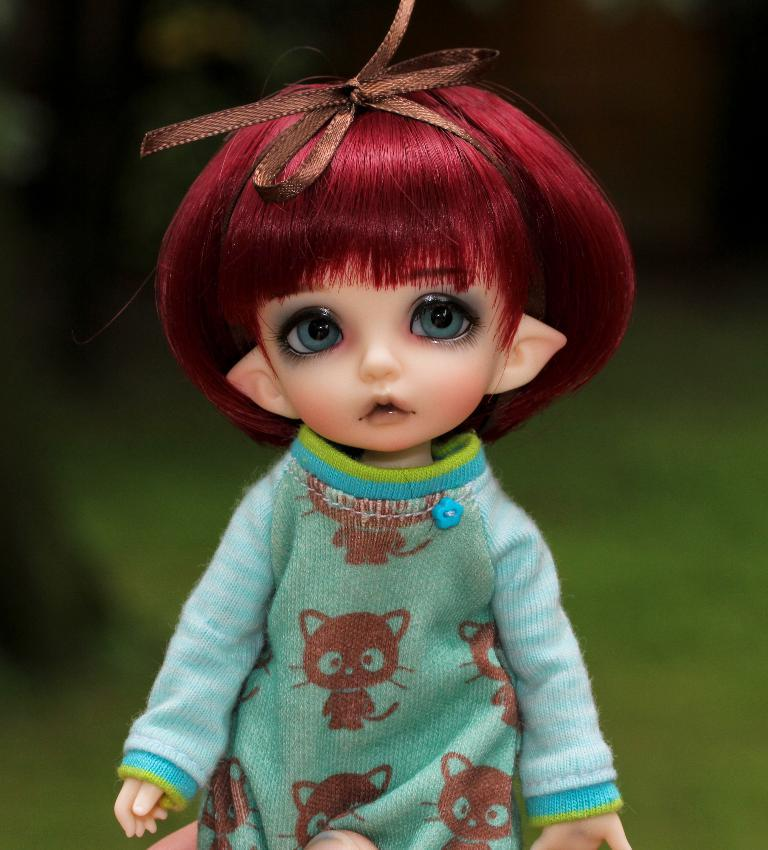What is the main subject in the image? There is a doll in the image. What type of environment is visible in the image? There is grass visible in the image. What type of glue is being used to hold the doll together in the image? There is no glue present in the image, and the doll does not appear to be held together by any adhesive. 